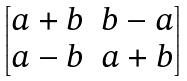<formula> <loc_0><loc_0><loc_500><loc_500>\begin{bmatrix} a + b & b - a \\ a - b & a + b \end{bmatrix}</formula> 